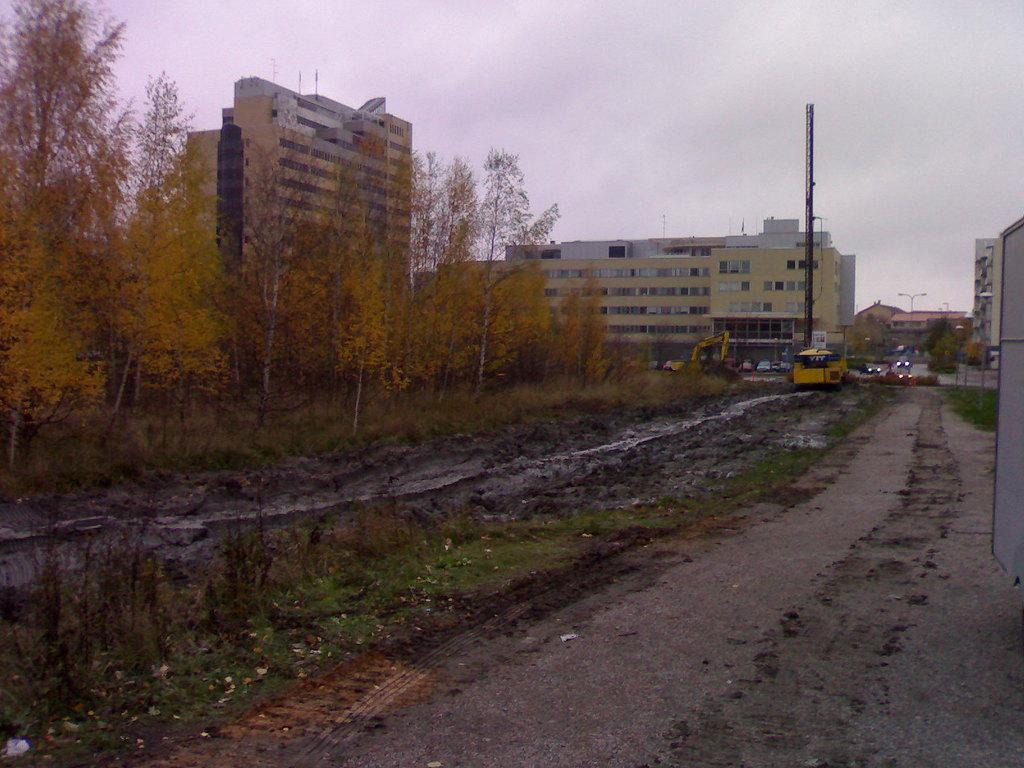What types of objects can be seen in the image? There are vehicles, buildings, and trees in the image. What is located at the bottom of the image? There is a road at the bottom of the image. How much profit does the passenger make in the image? There is no mention of passengers or profit in the image, as it primarily features vehicles, buildings, trees, and a road. 